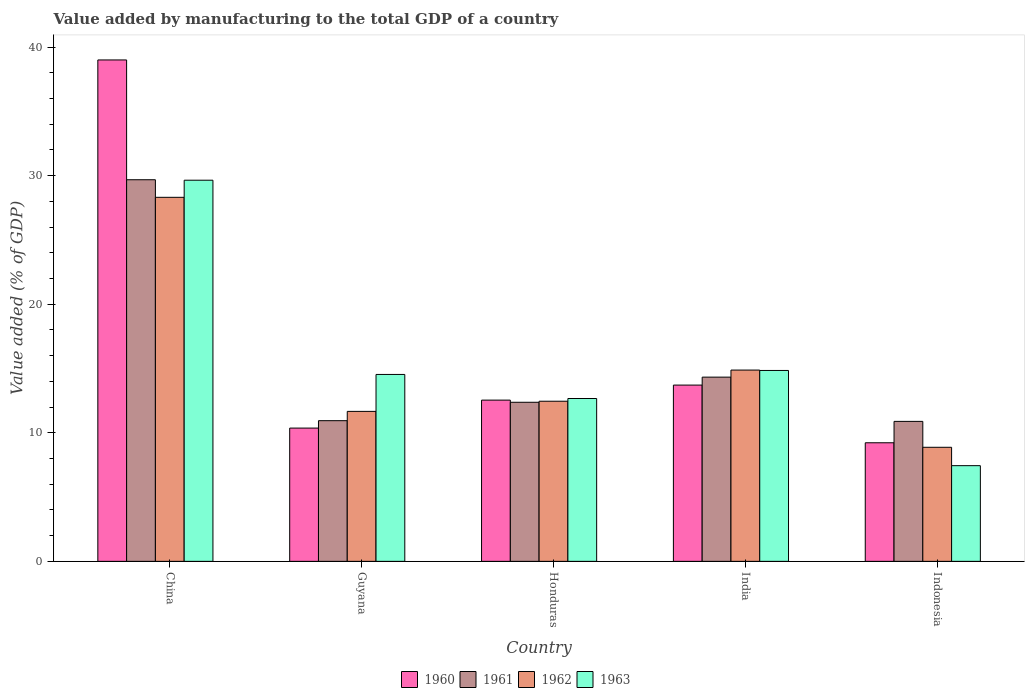How many different coloured bars are there?
Offer a very short reply. 4. Are the number of bars per tick equal to the number of legend labels?
Your answer should be compact. Yes. How many bars are there on the 1st tick from the left?
Provide a short and direct response. 4. What is the label of the 5th group of bars from the left?
Give a very brief answer. Indonesia. In how many cases, is the number of bars for a given country not equal to the number of legend labels?
Give a very brief answer. 0. What is the value added by manufacturing to the total GDP in 1962 in Indonesia?
Your response must be concise. 8.87. Across all countries, what is the maximum value added by manufacturing to the total GDP in 1962?
Provide a short and direct response. 28.31. Across all countries, what is the minimum value added by manufacturing to the total GDP in 1963?
Give a very brief answer. 7.44. In which country was the value added by manufacturing to the total GDP in 1961 maximum?
Your answer should be very brief. China. In which country was the value added by manufacturing to the total GDP in 1962 minimum?
Your answer should be very brief. Indonesia. What is the total value added by manufacturing to the total GDP in 1960 in the graph?
Your answer should be very brief. 84.84. What is the difference between the value added by manufacturing to the total GDP in 1960 in China and that in Guyana?
Ensure brevity in your answer.  28.63. What is the difference between the value added by manufacturing to the total GDP in 1961 in Honduras and the value added by manufacturing to the total GDP in 1960 in Guyana?
Ensure brevity in your answer.  2.01. What is the average value added by manufacturing to the total GDP in 1961 per country?
Provide a succinct answer. 15.64. What is the difference between the value added by manufacturing to the total GDP of/in 1962 and value added by manufacturing to the total GDP of/in 1963 in Indonesia?
Make the answer very short. 1.43. In how many countries, is the value added by manufacturing to the total GDP in 1963 greater than 4 %?
Provide a succinct answer. 5. What is the ratio of the value added by manufacturing to the total GDP in 1961 in Guyana to that in Indonesia?
Offer a very short reply. 1. What is the difference between the highest and the second highest value added by manufacturing to the total GDP in 1963?
Provide a succinct answer. 14.8. What is the difference between the highest and the lowest value added by manufacturing to the total GDP in 1963?
Your answer should be very brief. 22.2. Is the sum of the value added by manufacturing to the total GDP in 1962 in India and Indonesia greater than the maximum value added by manufacturing to the total GDP in 1961 across all countries?
Your answer should be very brief. No. Is it the case that in every country, the sum of the value added by manufacturing to the total GDP in 1961 and value added by manufacturing to the total GDP in 1960 is greater than the sum of value added by manufacturing to the total GDP in 1963 and value added by manufacturing to the total GDP in 1962?
Your answer should be very brief. Yes. How many bars are there?
Your response must be concise. 20. What is the difference between two consecutive major ticks on the Y-axis?
Ensure brevity in your answer.  10. Where does the legend appear in the graph?
Your answer should be very brief. Bottom center. How are the legend labels stacked?
Offer a terse response. Horizontal. What is the title of the graph?
Give a very brief answer. Value added by manufacturing to the total GDP of a country. What is the label or title of the X-axis?
Make the answer very short. Country. What is the label or title of the Y-axis?
Offer a terse response. Value added (% of GDP). What is the Value added (% of GDP) in 1960 in China?
Your response must be concise. 39. What is the Value added (% of GDP) in 1961 in China?
Offer a terse response. 29.68. What is the Value added (% of GDP) in 1962 in China?
Provide a succinct answer. 28.31. What is the Value added (% of GDP) of 1963 in China?
Your answer should be compact. 29.64. What is the Value added (% of GDP) in 1960 in Guyana?
Make the answer very short. 10.37. What is the Value added (% of GDP) of 1961 in Guyana?
Offer a terse response. 10.94. What is the Value added (% of GDP) of 1962 in Guyana?
Provide a succinct answer. 11.66. What is the Value added (% of GDP) in 1963 in Guyana?
Give a very brief answer. 14.54. What is the Value added (% of GDP) in 1960 in Honduras?
Offer a very short reply. 12.54. What is the Value added (% of GDP) of 1961 in Honduras?
Make the answer very short. 12.37. What is the Value added (% of GDP) of 1962 in Honduras?
Your answer should be compact. 12.45. What is the Value added (% of GDP) in 1963 in Honduras?
Offer a very short reply. 12.67. What is the Value added (% of GDP) in 1960 in India?
Provide a succinct answer. 13.71. What is the Value added (% of GDP) in 1961 in India?
Provide a short and direct response. 14.33. What is the Value added (% of GDP) in 1962 in India?
Provide a short and direct response. 14.88. What is the Value added (% of GDP) in 1963 in India?
Provide a short and direct response. 14.85. What is the Value added (% of GDP) in 1960 in Indonesia?
Provide a succinct answer. 9.22. What is the Value added (% of GDP) of 1961 in Indonesia?
Your answer should be compact. 10.89. What is the Value added (% of GDP) in 1962 in Indonesia?
Offer a terse response. 8.87. What is the Value added (% of GDP) of 1963 in Indonesia?
Your response must be concise. 7.44. Across all countries, what is the maximum Value added (% of GDP) of 1960?
Make the answer very short. 39. Across all countries, what is the maximum Value added (% of GDP) of 1961?
Offer a very short reply. 29.68. Across all countries, what is the maximum Value added (% of GDP) in 1962?
Provide a succinct answer. 28.31. Across all countries, what is the maximum Value added (% of GDP) in 1963?
Keep it short and to the point. 29.64. Across all countries, what is the minimum Value added (% of GDP) in 1960?
Your response must be concise. 9.22. Across all countries, what is the minimum Value added (% of GDP) in 1961?
Give a very brief answer. 10.89. Across all countries, what is the minimum Value added (% of GDP) of 1962?
Keep it short and to the point. 8.87. Across all countries, what is the minimum Value added (% of GDP) in 1963?
Your answer should be compact. 7.44. What is the total Value added (% of GDP) in 1960 in the graph?
Make the answer very short. 84.84. What is the total Value added (% of GDP) of 1961 in the graph?
Provide a succinct answer. 78.21. What is the total Value added (% of GDP) of 1962 in the graph?
Your response must be concise. 76.18. What is the total Value added (% of GDP) in 1963 in the graph?
Offer a terse response. 79.14. What is the difference between the Value added (% of GDP) of 1960 in China and that in Guyana?
Provide a short and direct response. 28.63. What is the difference between the Value added (% of GDP) of 1961 in China and that in Guyana?
Make the answer very short. 18.74. What is the difference between the Value added (% of GDP) in 1962 in China and that in Guyana?
Give a very brief answer. 16.65. What is the difference between the Value added (% of GDP) of 1963 in China and that in Guyana?
Give a very brief answer. 15.11. What is the difference between the Value added (% of GDP) in 1960 in China and that in Honduras?
Provide a short and direct response. 26.46. What is the difference between the Value added (% of GDP) of 1961 in China and that in Honduras?
Your response must be concise. 17.31. What is the difference between the Value added (% of GDP) in 1962 in China and that in Honduras?
Make the answer very short. 15.86. What is the difference between the Value added (% of GDP) of 1963 in China and that in Honduras?
Ensure brevity in your answer.  16.98. What is the difference between the Value added (% of GDP) in 1960 in China and that in India?
Make the answer very short. 25.29. What is the difference between the Value added (% of GDP) of 1961 in China and that in India?
Provide a succinct answer. 15.35. What is the difference between the Value added (% of GDP) in 1962 in China and that in India?
Offer a very short reply. 13.43. What is the difference between the Value added (% of GDP) of 1963 in China and that in India?
Offer a terse response. 14.8. What is the difference between the Value added (% of GDP) in 1960 in China and that in Indonesia?
Your answer should be compact. 29.77. What is the difference between the Value added (% of GDP) of 1961 in China and that in Indonesia?
Keep it short and to the point. 18.79. What is the difference between the Value added (% of GDP) of 1962 in China and that in Indonesia?
Ensure brevity in your answer.  19.44. What is the difference between the Value added (% of GDP) of 1963 in China and that in Indonesia?
Offer a terse response. 22.2. What is the difference between the Value added (% of GDP) of 1960 in Guyana and that in Honduras?
Your answer should be very brief. -2.18. What is the difference between the Value added (% of GDP) in 1961 in Guyana and that in Honduras?
Your response must be concise. -1.43. What is the difference between the Value added (% of GDP) in 1962 in Guyana and that in Honduras?
Provide a succinct answer. -0.79. What is the difference between the Value added (% of GDP) of 1963 in Guyana and that in Honduras?
Keep it short and to the point. 1.87. What is the difference between the Value added (% of GDP) in 1960 in Guyana and that in India?
Your response must be concise. -3.34. What is the difference between the Value added (% of GDP) of 1961 in Guyana and that in India?
Ensure brevity in your answer.  -3.39. What is the difference between the Value added (% of GDP) of 1962 in Guyana and that in India?
Your answer should be compact. -3.21. What is the difference between the Value added (% of GDP) in 1963 in Guyana and that in India?
Offer a very short reply. -0.31. What is the difference between the Value added (% of GDP) of 1960 in Guyana and that in Indonesia?
Keep it short and to the point. 1.14. What is the difference between the Value added (% of GDP) in 1961 in Guyana and that in Indonesia?
Give a very brief answer. 0.05. What is the difference between the Value added (% of GDP) of 1962 in Guyana and that in Indonesia?
Make the answer very short. 2.79. What is the difference between the Value added (% of GDP) of 1963 in Guyana and that in Indonesia?
Give a very brief answer. 7.09. What is the difference between the Value added (% of GDP) in 1960 in Honduras and that in India?
Your answer should be compact. -1.17. What is the difference between the Value added (% of GDP) of 1961 in Honduras and that in India?
Provide a succinct answer. -1.96. What is the difference between the Value added (% of GDP) of 1962 in Honduras and that in India?
Ensure brevity in your answer.  -2.42. What is the difference between the Value added (% of GDP) of 1963 in Honduras and that in India?
Ensure brevity in your answer.  -2.18. What is the difference between the Value added (% of GDP) of 1960 in Honduras and that in Indonesia?
Offer a very short reply. 3.32. What is the difference between the Value added (% of GDP) of 1961 in Honduras and that in Indonesia?
Provide a short and direct response. 1.49. What is the difference between the Value added (% of GDP) in 1962 in Honduras and that in Indonesia?
Give a very brief answer. 3.58. What is the difference between the Value added (% of GDP) in 1963 in Honduras and that in Indonesia?
Make the answer very short. 5.22. What is the difference between the Value added (% of GDP) in 1960 in India and that in Indonesia?
Make the answer very short. 4.49. What is the difference between the Value added (% of GDP) of 1961 in India and that in Indonesia?
Your response must be concise. 3.44. What is the difference between the Value added (% of GDP) of 1962 in India and that in Indonesia?
Keep it short and to the point. 6.01. What is the difference between the Value added (% of GDP) of 1963 in India and that in Indonesia?
Offer a terse response. 7.4. What is the difference between the Value added (% of GDP) in 1960 in China and the Value added (% of GDP) in 1961 in Guyana?
Your response must be concise. 28.06. What is the difference between the Value added (% of GDP) of 1960 in China and the Value added (% of GDP) of 1962 in Guyana?
Provide a succinct answer. 27.33. What is the difference between the Value added (% of GDP) of 1960 in China and the Value added (% of GDP) of 1963 in Guyana?
Make the answer very short. 24.46. What is the difference between the Value added (% of GDP) of 1961 in China and the Value added (% of GDP) of 1962 in Guyana?
Provide a short and direct response. 18.02. What is the difference between the Value added (% of GDP) in 1961 in China and the Value added (% of GDP) in 1963 in Guyana?
Keep it short and to the point. 15.14. What is the difference between the Value added (% of GDP) of 1962 in China and the Value added (% of GDP) of 1963 in Guyana?
Your answer should be compact. 13.78. What is the difference between the Value added (% of GDP) of 1960 in China and the Value added (% of GDP) of 1961 in Honduras?
Your response must be concise. 26.63. What is the difference between the Value added (% of GDP) in 1960 in China and the Value added (% of GDP) in 1962 in Honduras?
Your answer should be very brief. 26.54. What is the difference between the Value added (% of GDP) in 1960 in China and the Value added (% of GDP) in 1963 in Honduras?
Ensure brevity in your answer.  26.33. What is the difference between the Value added (% of GDP) in 1961 in China and the Value added (% of GDP) in 1962 in Honduras?
Make the answer very short. 17.23. What is the difference between the Value added (% of GDP) of 1961 in China and the Value added (% of GDP) of 1963 in Honduras?
Provide a short and direct response. 17.01. What is the difference between the Value added (% of GDP) of 1962 in China and the Value added (% of GDP) of 1963 in Honduras?
Your answer should be very brief. 15.65. What is the difference between the Value added (% of GDP) of 1960 in China and the Value added (% of GDP) of 1961 in India?
Your answer should be compact. 24.67. What is the difference between the Value added (% of GDP) in 1960 in China and the Value added (% of GDP) in 1962 in India?
Offer a terse response. 24.12. What is the difference between the Value added (% of GDP) of 1960 in China and the Value added (% of GDP) of 1963 in India?
Provide a succinct answer. 24.15. What is the difference between the Value added (% of GDP) of 1961 in China and the Value added (% of GDP) of 1962 in India?
Give a very brief answer. 14.8. What is the difference between the Value added (% of GDP) in 1961 in China and the Value added (% of GDP) in 1963 in India?
Offer a very short reply. 14.83. What is the difference between the Value added (% of GDP) in 1962 in China and the Value added (% of GDP) in 1963 in India?
Your response must be concise. 13.47. What is the difference between the Value added (% of GDP) of 1960 in China and the Value added (% of GDP) of 1961 in Indonesia?
Your response must be concise. 28.11. What is the difference between the Value added (% of GDP) in 1960 in China and the Value added (% of GDP) in 1962 in Indonesia?
Keep it short and to the point. 30.13. What is the difference between the Value added (% of GDP) of 1960 in China and the Value added (% of GDP) of 1963 in Indonesia?
Provide a short and direct response. 31.56. What is the difference between the Value added (% of GDP) of 1961 in China and the Value added (% of GDP) of 1962 in Indonesia?
Your response must be concise. 20.81. What is the difference between the Value added (% of GDP) of 1961 in China and the Value added (% of GDP) of 1963 in Indonesia?
Ensure brevity in your answer.  22.24. What is the difference between the Value added (% of GDP) of 1962 in China and the Value added (% of GDP) of 1963 in Indonesia?
Your response must be concise. 20.87. What is the difference between the Value added (% of GDP) in 1960 in Guyana and the Value added (% of GDP) in 1961 in Honduras?
Ensure brevity in your answer.  -2.01. What is the difference between the Value added (% of GDP) in 1960 in Guyana and the Value added (% of GDP) in 1962 in Honduras?
Your answer should be very brief. -2.09. What is the difference between the Value added (% of GDP) of 1960 in Guyana and the Value added (% of GDP) of 1963 in Honduras?
Keep it short and to the point. -2.3. What is the difference between the Value added (% of GDP) in 1961 in Guyana and the Value added (% of GDP) in 1962 in Honduras?
Offer a terse response. -1.51. What is the difference between the Value added (% of GDP) in 1961 in Guyana and the Value added (% of GDP) in 1963 in Honduras?
Offer a very short reply. -1.73. What is the difference between the Value added (% of GDP) of 1962 in Guyana and the Value added (% of GDP) of 1963 in Honduras?
Keep it short and to the point. -1. What is the difference between the Value added (% of GDP) in 1960 in Guyana and the Value added (% of GDP) in 1961 in India?
Keep it short and to the point. -3.96. What is the difference between the Value added (% of GDP) in 1960 in Guyana and the Value added (% of GDP) in 1962 in India?
Make the answer very short. -4.51. What is the difference between the Value added (% of GDP) of 1960 in Guyana and the Value added (% of GDP) of 1963 in India?
Your response must be concise. -4.48. What is the difference between the Value added (% of GDP) in 1961 in Guyana and the Value added (% of GDP) in 1962 in India?
Provide a short and direct response. -3.94. What is the difference between the Value added (% of GDP) of 1961 in Guyana and the Value added (% of GDP) of 1963 in India?
Keep it short and to the point. -3.91. What is the difference between the Value added (% of GDP) of 1962 in Guyana and the Value added (% of GDP) of 1963 in India?
Make the answer very short. -3.18. What is the difference between the Value added (% of GDP) of 1960 in Guyana and the Value added (% of GDP) of 1961 in Indonesia?
Your answer should be very brief. -0.52. What is the difference between the Value added (% of GDP) of 1960 in Guyana and the Value added (% of GDP) of 1962 in Indonesia?
Offer a terse response. 1.49. What is the difference between the Value added (% of GDP) of 1960 in Guyana and the Value added (% of GDP) of 1963 in Indonesia?
Offer a terse response. 2.92. What is the difference between the Value added (% of GDP) in 1961 in Guyana and the Value added (% of GDP) in 1962 in Indonesia?
Offer a very short reply. 2.07. What is the difference between the Value added (% of GDP) in 1961 in Guyana and the Value added (% of GDP) in 1963 in Indonesia?
Give a very brief answer. 3.5. What is the difference between the Value added (% of GDP) in 1962 in Guyana and the Value added (% of GDP) in 1963 in Indonesia?
Make the answer very short. 4.22. What is the difference between the Value added (% of GDP) in 1960 in Honduras and the Value added (% of GDP) in 1961 in India?
Your answer should be compact. -1.79. What is the difference between the Value added (% of GDP) in 1960 in Honduras and the Value added (% of GDP) in 1962 in India?
Provide a succinct answer. -2.34. What is the difference between the Value added (% of GDP) of 1960 in Honduras and the Value added (% of GDP) of 1963 in India?
Your response must be concise. -2.31. What is the difference between the Value added (% of GDP) in 1961 in Honduras and the Value added (% of GDP) in 1962 in India?
Make the answer very short. -2.51. What is the difference between the Value added (% of GDP) of 1961 in Honduras and the Value added (% of GDP) of 1963 in India?
Offer a very short reply. -2.47. What is the difference between the Value added (% of GDP) of 1962 in Honduras and the Value added (% of GDP) of 1963 in India?
Your answer should be very brief. -2.39. What is the difference between the Value added (% of GDP) in 1960 in Honduras and the Value added (% of GDP) in 1961 in Indonesia?
Your answer should be compact. 1.65. What is the difference between the Value added (% of GDP) of 1960 in Honduras and the Value added (% of GDP) of 1962 in Indonesia?
Provide a short and direct response. 3.67. What is the difference between the Value added (% of GDP) in 1960 in Honduras and the Value added (% of GDP) in 1963 in Indonesia?
Your answer should be very brief. 5.1. What is the difference between the Value added (% of GDP) in 1961 in Honduras and the Value added (% of GDP) in 1962 in Indonesia?
Your answer should be compact. 3.5. What is the difference between the Value added (% of GDP) in 1961 in Honduras and the Value added (% of GDP) in 1963 in Indonesia?
Provide a short and direct response. 4.93. What is the difference between the Value added (% of GDP) of 1962 in Honduras and the Value added (% of GDP) of 1963 in Indonesia?
Provide a succinct answer. 5.01. What is the difference between the Value added (% of GDP) of 1960 in India and the Value added (% of GDP) of 1961 in Indonesia?
Provide a succinct answer. 2.82. What is the difference between the Value added (% of GDP) in 1960 in India and the Value added (% of GDP) in 1962 in Indonesia?
Keep it short and to the point. 4.84. What is the difference between the Value added (% of GDP) of 1960 in India and the Value added (% of GDP) of 1963 in Indonesia?
Offer a terse response. 6.27. What is the difference between the Value added (% of GDP) of 1961 in India and the Value added (% of GDP) of 1962 in Indonesia?
Give a very brief answer. 5.46. What is the difference between the Value added (% of GDP) in 1961 in India and the Value added (% of GDP) in 1963 in Indonesia?
Provide a succinct answer. 6.89. What is the difference between the Value added (% of GDP) in 1962 in India and the Value added (% of GDP) in 1963 in Indonesia?
Keep it short and to the point. 7.44. What is the average Value added (% of GDP) of 1960 per country?
Ensure brevity in your answer.  16.97. What is the average Value added (% of GDP) of 1961 per country?
Ensure brevity in your answer.  15.64. What is the average Value added (% of GDP) of 1962 per country?
Make the answer very short. 15.24. What is the average Value added (% of GDP) of 1963 per country?
Your answer should be compact. 15.83. What is the difference between the Value added (% of GDP) of 1960 and Value added (% of GDP) of 1961 in China?
Provide a succinct answer. 9.32. What is the difference between the Value added (% of GDP) in 1960 and Value added (% of GDP) in 1962 in China?
Your answer should be compact. 10.69. What is the difference between the Value added (% of GDP) in 1960 and Value added (% of GDP) in 1963 in China?
Make the answer very short. 9.35. What is the difference between the Value added (% of GDP) in 1961 and Value added (% of GDP) in 1962 in China?
Your answer should be compact. 1.37. What is the difference between the Value added (% of GDP) in 1961 and Value added (% of GDP) in 1963 in China?
Ensure brevity in your answer.  0.04. What is the difference between the Value added (% of GDP) of 1962 and Value added (% of GDP) of 1963 in China?
Your answer should be compact. -1.33. What is the difference between the Value added (% of GDP) in 1960 and Value added (% of GDP) in 1961 in Guyana?
Your answer should be very brief. -0.58. What is the difference between the Value added (% of GDP) of 1960 and Value added (% of GDP) of 1962 in Guyana?
Offer a very short reply. -1.3. What is the difference between the Value added (% of GDP) of 1960 and Value added (% of GDP) of 1963 in Guyana?
Ensure brevity in your answer.  -4.17. What is the difference between the Value added (% of GDP) of 1961 and Value added (% of GDP) of 1962 in Guyana?
Your answer should be very brief. -0.72. What is the difference between the Value added (% of GDP) of 1961 and Value added (% of GDP) of 1963 in Guyana?
Offer a terse response. -3.6. What is the difference between the Value added (% of GDP) of 1962 and Value added (% of GDP) of 1963 in Guyana?
Your response must be concise. -2.87. What is the difference between the Value added (% of GDP) of 1960 and Value added (% of GDP) of 1961 in Honduras?
Offer a terse response. 0.17. What is the difference between the Value added (% of GDP) of 1960 and Value added (% of GDP) of 1962 in Honduras?
Ensure brevity in your answer.  0.09. What is the difference between the Value added (% of GDP) in 1960 and Value added (% of GDP) in 1963 in Honduras?
Give a very brief answer. -0.13. What is the difference between the Value added (% of GDP) of 1961 and Value added (% of GDP) of 1962 in Honduras?
Your response must be concise. -0.08. What is the difference between the Value added (% of GDP) of 1961 and Value added (% of GDP) of 1963 in Honduras?
Offer a very short reply. -0.29. What is the difference between the Value added (% of GDP) of 1962 and Value added (% of GDP) of 1963 in Honduras?
Provide a short and direct response. -0.21. What is the difference between the Value added (% of GDP) of 1960 and Value added (% of GDP) of 1961 in India?
Ensure brevity in your answer.  -0.62. What is the difference between the Value added (% of GDP) in 1960 and Value added (% of GDP) in 1962 in India?
Keep it short and to the point. -1.17. What is the difference between the Value added (% of GDP) in 1960 and Value added (% of GDP) in 1963 in India?
Offer a terse response. -1.14. What is the difference between the Value added (% of GDP) in 1961 and Value added (% of GDP) in 1962 in India?
Ensure brevity in your answer.  -0.55. What is the difference between the Value added (% of GDP) of 1961 and Value added (% of GDP) of 1963 in India?
Keep it short and to the point. -0.52. What is the difference between the Value added (% of GDP) in 1962 and Value added (% of GDP) in 1963 in India?
Your response must be concise. 0.03. What is the difference between the Value added (% of GDP) of 1960 and Value added (% of GDP) of 1961 in Indonesia?
Offer a very short reply. -1.66. What is the difference between the Value added (% of GDP) in 1960 and Value added (% of GDP) in 1962 in Indonesia?
Keep it short and to the point. 0.35. What is the difference between the Value added (% of GDP) in 1960 and Value added (% of GDP) in 1963 in Indonesia?
Your answer should be very brief. 1.78. What is the difference between the Value added (% of GDP) of 1961 and Value added (% of GDP) of 1962 in Indonesia?
Your response must be concise. 2.02. What is the difference between the Value added (% of GDP) in 1961 and Value added (% of GDP) in 1963 in Indonesia?
Your answer should be very brief. 3.44. What is the difference between the Value added (% of GDP) in 1962 and Value added (% of GDP) in 1963 in Indonesia?
Provide a short and direct response. 1.43. What is the ratio of the Value added (% of GDP) of 1960 in China to that in Guyana?
Offer a very short reply. 3.76. What is the ratio of the Value added (% of GDP) of 1961 in China to that in Guyana?
Make the answer very short. 2.71. What is the ratio of the Value added (% of GDP) in 1962 in China to that in Guyana?
Provide a short and direct response. 2.43. What is the ratio of the Value added (% of GDP) in 1963 in China to that in Guyana?
Offer a very short reply. 2.04. What is the ratio of the Value added (% of GDP) in 1960 in China to that in Honduras?
Provide a succinct answer. 3.11. What is the ratio of the Value added (% of GDP) in 1961 in China to that in Honduras?
Offer a terse response. 2.4. What is the ratio of the Value added (% of GDP) in 1962 in China to that in Honduras?
Keep it short and to the point. 2.27. What is the ratio of the Value added (% of GDP) of 1963 in China to that in Honduras?
Provide a short and direct response. 2.34. What is the ratio of the Value added (% of GDP) of 1960 in China to that in India?
Ensure brevity in your answer.  2.84. What is the ratio of the Value added (% of GDP) of 1961 in China to that in India?
Offer a terse response. 2.07. What is the ratio of the Value added (% of GDP) of 1962 in China to that in India?
Your answer should be compact. 1.9. What is the ratio of the Value added (% of GDP) in 1963 in China to that in India?
Your answer should be compact. 2. What is the ratio of the Value added (% of GDP) in 1960 in China to that in Indonesia?
Provide a succinct answer. 4.23. What is the ratio of the Value added (% of GDP) of 1961 in China to that in Indonesia?
Your answer should be compact. 2.73. What is the ratio of the Value added (% of GDP) in 1962 in China to that in Indonesia?
Offer a terse response. 3.19. What is the ratio of the Value added (% of GDP) of 1963 in China to that in Indonesia?
Keep it short and to the point. 3.98. What is the ratio of the Value added (% of GDP) in 1960 in Guyana to that in Honduras?
Make the answer very short. 0.83. What is the ratio of the Value added (% of GDP) of 1961 in Guyana to that in Honduras?
Keep it short and to the point. 0.88. What is the ratio of the Value added (% of GDP) in 1962 in Guyana to that in Honduras?
Offer a terse response. 0.94. What is the ratio of the Value added (% of GDP) of 1963 in Guyana to that in Honduras?
Make the answer very short. 1.15. What is the ratio of the Value added (% of GDP) of 1960 in Guyana to that in India?
Offer a terse response. 0.76. What is the ratio of the Value added (% of GDP) of 1961 in Guyana to that in India?
Your answer should be very brief. 0.76. What is the ratio of the Value added (% of GDP) of 1962 in Guyana to that in India?
Offer a very short reply. 0.78. What is the ratio of the Value added (% of GDP) in 1963 in Guyana to that in India?
Provide a succinct answer. 0.98. What is the ratio of the Value added (% of GDP) of 1960 in Guyana to that in Indonesia?
Your answer should be compact. 1.12. What is the ratio of the Value added (% of GDP) of 1961 in Guyana to that in Indonesia?
Your answer should be compact. 1. What is the ratio of the Value added (% of GDP) in 1962 in Guyana to that in Indonesia?
Your response must be concise. 1.31. What is the ratio of the Value added (% of GDP) of 1963 in Guyana to that in Indonesia?
Offer a terse response. 1.95. What is the ratio of the Value added (% of GDP) of 1960 in Honduras to that in India?
Your answer should be compact. 0.91. What is the ratio of the Value added (% of GDP) of 1961 in Honduras to that in India?
Ensure brevity in your answer.  0.86. What is the ratio of the Value added (% of GDP) in 1962 in Honduras to that in India?
Provide a succinct answer. 0.84. What is the ratio of the Value added (% of GDP) in 1963 in Honduras to that in India?
Your response must be concise. 0.85. What is the ratio of the Value added (% of GDP) in 1960 in Honduras to that in Indonesia?
Ensure brevity in your answer.  1.36. What is the ratio of the Value added (% of GDP) in 1961 in Honduras to that in Indonesia?
Provide a short and direct response. 1.14. What is the ratio of the Value added (% of GDP) of 1962 in Honduras to that in Indonesia?
Provide a short and direct response. 1.4. What is the ratio of the Value added (% of GDP) of 1963 in Honduras to that in Indonesia?
Ensure brevity in your answer.  1.7. What is the ratio of the Value added (% of GDP) in 1960 in India to that in Indonesia?
Keep it short and to the point. 1.49. What is the ratio of the Value added (% of GDP) of 1961 in India to that in Indonesia?
Offer a very short reply. 1.32. What is the ratio of the Value added (% of GDP) in 1962 in India to that in Indonesia?
Offer a terse response. 1.68. What is the ratio of the Value added (% of GDP) in 1963 in India to that in Indonesia?
Give a very brief answer. 1.99. What is the difference between the highest and the second highest Value added (% of GDP) of 1960?
Your answer should be compact. 25.29. What is the difference between the highest and the second highest Value added (% of GDP) of 1961?
Offer a very short reply. 15.35. What is the difference between the highest and the second highest Value added (% of GDP) of 1962?
Ensure brevity in your answer.  13.43. What is the difference between the highest and the second highest Value added (% of GDP) in 1963?
Provide a short and direct response. 14.8. What is the difference between the highest and the lowest Value added (% of GDP) in 1960?
Ensure brevity in your answer.  29.77. What is the difference between the highest and the lowest Value added (% of GDP) of 1961?
Make the answer very short. 18.79. What is the difference between the highest and the lowest Value added (% of GDP) in 1962?
Your answer should be very brief. 19.44. What is the difference between the highest and the lowest Value added (% of GDP) of 1963?
Offer a very short reply. 22.2. 